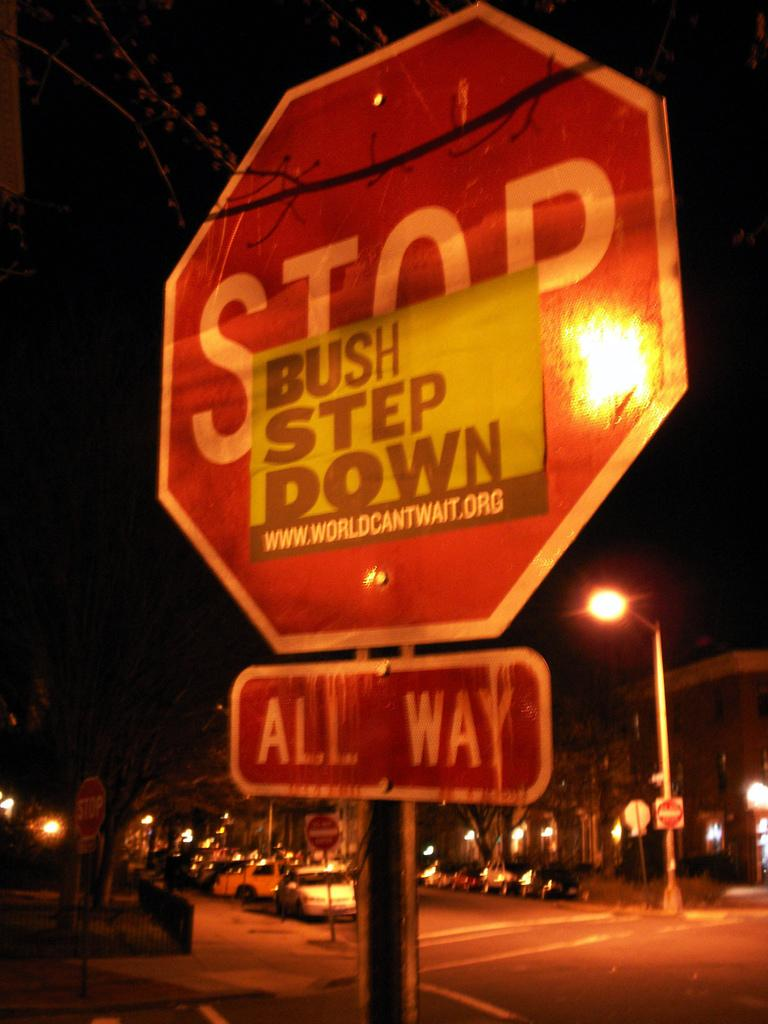<image>
Relay a brief, clear account of the picture shown. The small sign on the stop sign says Bush Step Down 